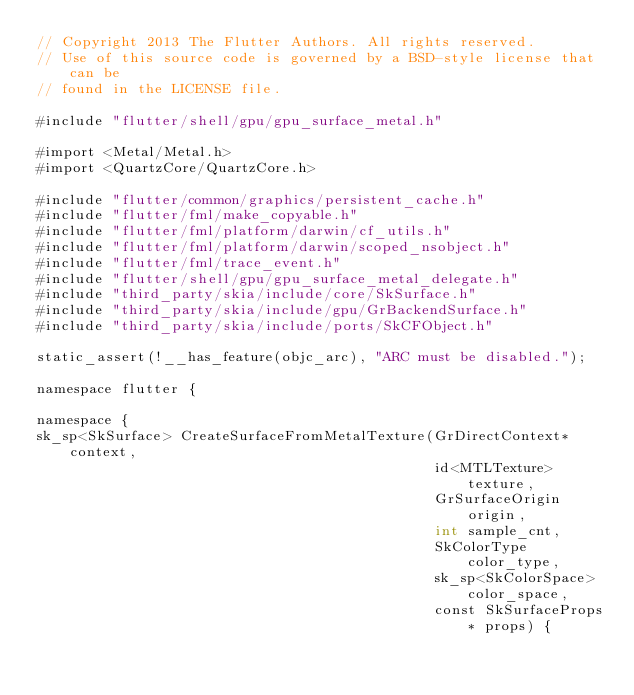<code> <loc_0><loc_0><loc_500><loc_500><_ObjectiveC_>// Copyright 2013 The Flutter Authors. All rights reserved.
// Use of this source code is governed by a BSD-style license that can be
// found in the LICENSE file.

#include "flutter/shell/gpu/gpu_surface_metal.h"

#import <Metal/Metal.h>
#import <QuartzCore/QuartzCore.h>

#include "flutter/common/graphics/persistent_cache.h"
#include "flutter/fml/make_copyable.h"
#include "flutter/fml/platform/darwin/cf_utils.h"
#include "flutter/fml/platform/darwin/scoped_nsobject.h"
#include "flutter/fml/trace_event.h"
#include "flutter/shell/gpu/gpu_surface_metal_delegate.h"
#include "third_party/skia/include/core/SkSurface.h"
#include "third_party/skia/include/gpu/GrBackendSurface.h"
#include "third_party/skia/include/ports/SkCFObject.h"

static_assert(!__has_feature(objc_arc), "ARC must be disabled.");

namespace flutter {

namespace {
sk_sp<SkSurface> CreateSurfaceFromMetalTexture(GrDirectContext* context,
                                               id<MTLTexture> texture,
                                               GrSurfaceOrigin origin,
                                               int sample_cnt,
                                               SkColorType color_type,
                                               sk_sp<SkColorSpace> color_space,
                                               const SkSurfaceProps* props) {</code> 